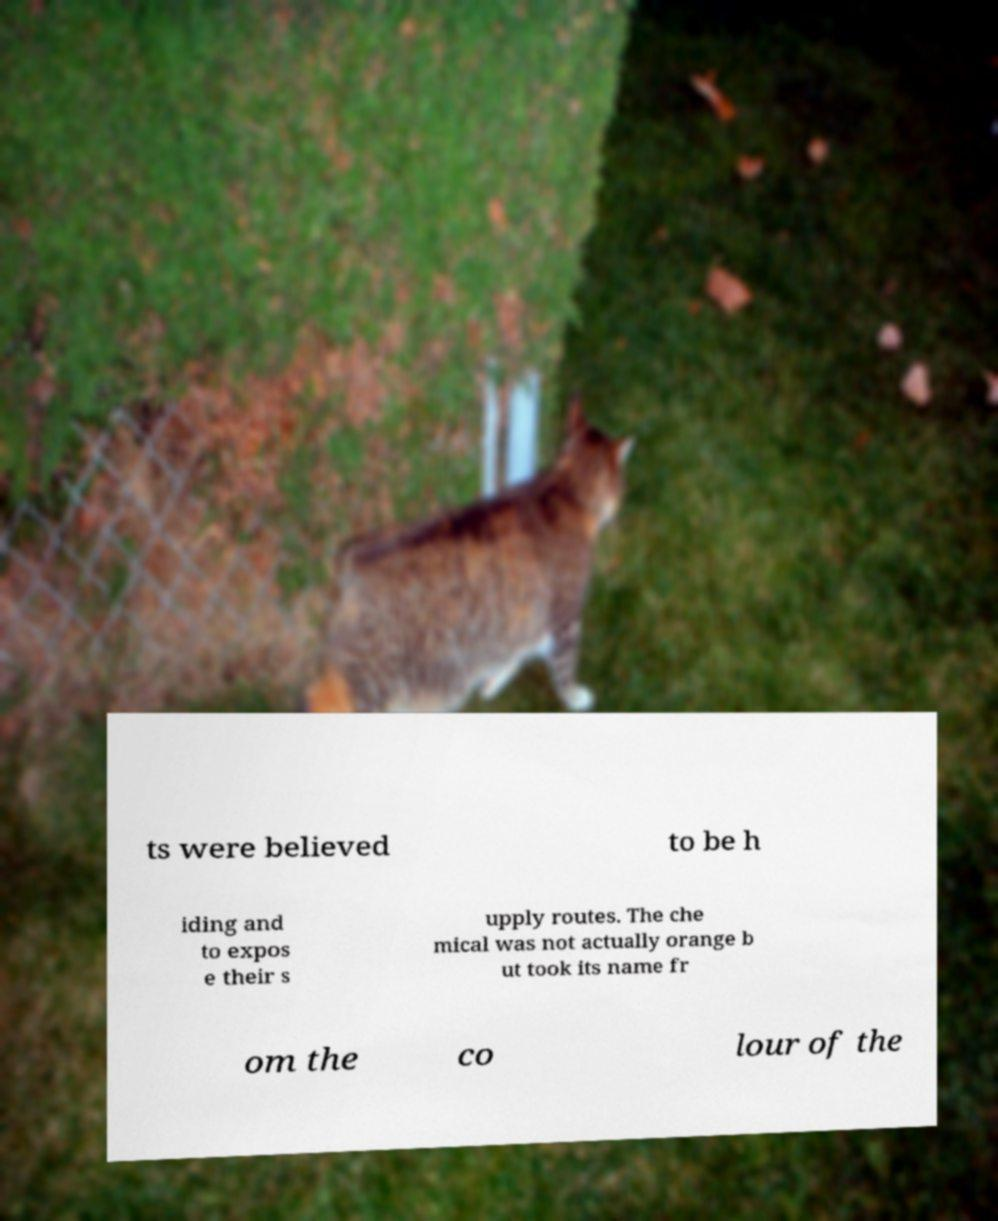Could you extract and type out the text from this image? ts were believed to be h iding and to expos e their s upply routes. The che mical was not actually orange b ut took its name fr om the co lour of the 